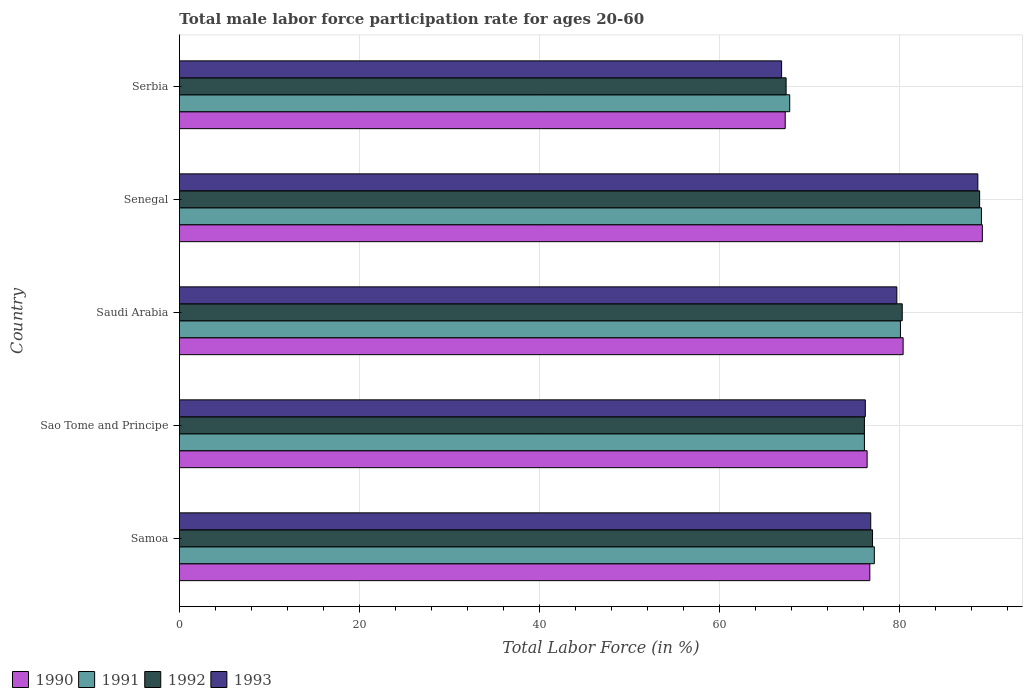How many groups of bars are there?
Your answer should be very brief. 5. Are the number of bars on each tick of the Y-axis equal?
Offer a very short reply. Yes. What is the label of the 4th group of bars from the top?
Provide a succinct answer. Sao Tome and Principe. What is the male labor force participation rate in 1991 in Samoa?
Keep it short and to the point. 77.2. Across all countries, what is the maximum male labor force participation rate in 1992?
Provide a succinct answer. 88.9. Across all countries, what is the minimum male labor force participation rate in 1990?
Give a very brief answer. 67.3. In which country was the male labor force participation rate in 1991 maximum?
Make the answer very short. Senegal. In which country was the male labor force participation rate in 1990 minimum?
Your answer should be compact. Serbia. What is the total male labor force participation rate in 1992 in the graph?
Give a very brief answer. 389.7. What is the average male labor force participation rate in 1993 per country?
Your response must be concise. 77.66. What is the difference between the male labor force participation rate in 1991 and male labor force participation rate in 1990 in Saudi Arabia?
Your response must be concise. -0.3. What is the ratio of the male labor force participation rate in 1993 in Sao Tome and Principe to that in Saudi Arabia?
Offer a very short reply. 0.96. Is the male labor force participation rate in 1993 in Samoa less than that in Senegal?
Your response must be concise. Yes. What is the difference between the highest and the second highest male labor force participation rate in 1993?
Make the answer very short. 9. What is the difference between the highest and the lowest male labor force participation rate in 1992?
Keep it short and to the point. 21.5. Is the sum of the male labor force participation rate in 1991 in Samoa and Senegal greater than the maximum male labor force participation rate in 1992 across all countries?
Offer a terse response. Yes. Is it the case that in every country, the sum of the male labor force participation rate in 1990 and male labor force participation rate in 1992 is greater than the sum of male labor force participation rate in 1991 and male labor force participation rate in 1993?
Provide a short and direct response. No. What does the 1st bar from the bottom in Senegal represents?
Your answer should be compact. 1990. How many bars are there?
Provide a short and direct response. 20. Are all the bars in the graph horizontal?
Provide a short and direct response. Yes. Are the values on the major ticks of X-axis written in scientific E-notation?
Make the answer very short. No. Does the graph contain grids?
Your answer should be compact. Yes. How many legend labels are there?
Offer a terse response. 4. How are the legend labels stacked?
Your response must be concise. Horizontal. What is the title of the graph?
Give a very brief answer. Total male labor force participation rate for ages 20-60. What is the label or title of the Y-axis?
Offer a very short reply. Country. What is the Total Labor Force (in %) of 1990 in Samoa?
Your answer should be very brief. 76.7. What is the Total Labor Force (in %) of 1991 in Samoa?
Provide a short and direct response. 77.2. What is the Total Labor Force (in %) of 1992 in Samoa?
Make the answer very short. 77. What is the Total Labor Force (in %) of 1993 in Samoa?
Make the answer very short. 76.8. What is the Total Labor Force (in %) of 1990 in Sao Tome and Principe?
Make the answer very short. 76.4. What is the Total Labor Force (in %) of 1991 in Sao Tome and Principe?
Give a very brief answer. 76.1. What is the Total Labor Force (in %) of 1992 in Sao Tome and Principe?
Your answer should be very brief. 76.1. What is the Total Labor Force (in %) of 1993 in Sao Tome and Principe?
Provide a succinct answer. 76.2. What is the Total Labor Force (in %) in 1990 in Saudi Arabia?
Offer a terse response. 80.4. What is the Total Labor Force (in %) in 1991 in Saudi Arabia?
Your response must be concise. 80.1. What is the Total Labor Force (in %) in 1992 in Saudi Arabia?
Offer a very short reply. 80.3. What is the Total Labor Force (in %) in 1993 in Saudi Arabia?
Offer a very short reply. 79.7. What is the Total Labor Force (in %) in 1990 in Senegal?
Offer a terse response. 89.2. What is the Total Labor Force (in %) of 1991 in Senegal?
Offer a terse response. 89.1. What is the Total Labor Force (in %) in 1992 in Senegal?
Give a very brief answer. 88.9. What is the Total Labor Force (in %) of 1993 in Senegal?
Make the answer very short. 88.7. What is the Total Labor Force (in %) of 1990 in Serbia?
Your response must be concise. 67.3. What is the Total Labor Force (in %) in 1991 in Serbia?
Provide a succinct answer. 67.8. What is the Total Labor Force (in %) in 1992 in Serbia?
Provide a succinct answer. 67.4. What is the Total Labor Force (in %) in 1993 in Serbia?
Offer a very short reply. 66.9. Across all countries, what is the maximum Total Labor Force (in %) in 1990?
Offer a very short reply. 89.2. Across all countries, what is the maximum Total Labor Force (in %) of 1991?
Give a very brief answer. 89.1. Across all countries, what is the maximum Total Labor Force (in %) in 1992?
Keep it short and to the point. 88.9. Across all countries, what is the maximum Total Labor Force (in %) of 1993?
Offer a terse response. 88.7. Across all countries, what is the minimum Total Labor Force (in %) in 1990?
Provide a succinct answer. 67.3. Across all countries, what is the minimum Total Labor Force (in %) in 1991?
Keep it short and to the point. 67.8. Across all countries, what is the minimum Total Labor Force (in %) in 1992?
Give a very brief answer. 67.4. Across all countries, what is the minimum Total Labor Force (in %) of 1993?
Your answer should be very brief. 66.9. What is the total Total Labor Force (in %) of 1990 in the graph?
Keep it short and to the point. 390. What is the total Total Labor Force (in %) of 1991 in the graph?
Your answer should be very brief. 390.3. What is the total Total Labor Force (in %) of 1992 in the graph?
Give a very brief answer. 389.7. What is the total Total Labor Force (in %) in 1993 in the graph?
Offer a terse response. 388.3. What is the difference between the Total Labor Force (in %) of 1991 in Samoa and that in Sao Tome and Principe?
Give a very brief answer. 1.1. What is the difference between the Total Labor Force (in %) of 1992 in Samoa and that in Senegal?
Provide a short and direct response. -11.9. What is the difference between the Total Labor Force (in %) in 1991 in Samoa and that in Serbia?
Provide a short and direct response. 9.4. What is the difference between the Total Labor Force (in %) in 1992 in Samoa and that in Serbia?
Keep it short and to the point. 9.6. What is the difference between the Total Labor Force (in %) in 1993 in Samoa and that in Serbia?
Make the answer very short. 9.9. What is the difference between the Total Labor Force (in %) in 1991 in Sao Tome and Principe and that in Saudi Arabia?
Ensure brevity in your answer.  -4. What is the difference between the Total Labor Force (in %) in 1992 in Sao Tome and Principe and that in Saudi Arabia?
Provide a succinct answer. -4.2. What is the difference between the Total Labor Force (in %) of 1990 in Sao Tome and Principe and that in Senegal?
Ensure brevity in your answer.  -12.8. What is the difference between the Total Labor Force (in %) in 1993 in Sao Tome and Principe and that in Senegal?
Ensure brevity in your answer.  -12.5. What is the difference between the Total Labor Force (in %) of 1992 in Sao Tome and Principe and that in Serbia?
Make the answer very short. 8.7. What is the difference between the Total Labor Force (in %) of 1991 in Saudi Arabia and that in Senegal?
Make the answer very short. -9. What is the difference between the Total Labor Force (in %) in 1992 in Saudi Arabia and that in Senegal?
Your answer should be very brief. -8.6. What is the difference between the Total Labor Force (in %) of 1993 in Saudi Arabia and that in Senegal?
Your answer should be very brief. -9. What is the difference between the Total Labor Force (in %) of 1992 in Saudi Arabia and that in Serbia?
Provide a succinct answer. 12.9. What is the difference between the Total Labor Force (in %) of 1993 in Saudi Arabia and that in Serbia?
Provide a succinct answer. 12.8. What is the difference between the Total Labor Force (in %) in 1990 in Senegal and that in Serbia?
Ensure brevity in your answer.  21.9. What is the difference between the Total Labor Force (in %) of 1991 in Senegal and that in Serbia?
Your answer should be compact. 21.3. What is the difference between the Total Labor Force (in %) of 1992 in Senegal and that in Serbia?
Offer a terse response. 21.5. What is the difference between the Total Labor Force (in %) of 1993 in Senegal and that in Serbia?
Make the answer very short. 21.8. What is the difference between the Total Labor Force (in %) in 1991 in Samoa and the Total Labor Force (in %) in 1992 in Sao Tome and Principe?
Keep it short and to the point. 1.1. What is the difference between the Total Labor Force (in %) of 1992 in Samoa and the Total Labor Force (in %) of 1993 in Sao Tome and Principe?
Your answer should be very brief. 0.8. What is the difference between the Total Labor Force (in %) in 1990 in Samoa and the Total Labor Force (in %) in 1991 in Senegal?
Give a very brief answer. -12.4. What is the difference between the Total Labor Force (in %) of 1990 in Samoa and the Total Labor Force (in %) of 1992 in Senegal?
Keep it short and to the point. -12.2. What is the difference between the Total Labor Force (in %) in 1990 in Samoa and the Total Labor Force (in %) in 1993 in Senegal?
Ensure brevity in your answer.  -12. What is the difference between the Total Labor Force (in %) of 1991 in Samoa and the Total Labor Force (in %) of 1992 in Senegal?
Your response must be concise. -11.7. What is the difference between the Total Labor Force (in %) in 1990 in Samoa and the Total Labor Force (in %) in 1992 in Serbia?
Ensure brevity in your answer.  9.3. What is the difference between the Total Labor Force (in %) in 1990 in Samoa and the Total Labor Force (in %) in 1993 in Serbia?
Give a very brief answer. 9.8. What is the difference between the Total Labor Force (in %) in 1991 in Samoa and the Total Labor Force (in %) in 1993 in Serbia?
Provide a short and direct response. 10.3. What is the difference between the Total Labor Force (in %) of 1992 in Samoa and the Total Labor Force (in %) of 1993 in Serbia?
Offer a terse response. 10.1. What is the difference between the Total Labor Force (in %) in 1990 in Sao Tome and Principe and the Total Labor Force (in %) in 1992 in Saudi Arabia?
Your answer should be compact. -3.9. What is the difference between the Total Labor Force (in %) of 1990 in Sao Tome and Principe and the Total Labor Force (in %) of 1993 in Saudi Arabia?
Your response must be concise. -3.3. What is the difference between the Total Labor Force (in %) in 1992 in Sao Tome and Principe and the Total Labor Force (in %) in 1993 in Saudi Arabia?
Your answer should be compact. -3.6. What is the difference between the Total Labor Force (in %) of 1990 in Sao Tome and Principe and the Total Labor Force (in %) of 1991 in Senegal?
Your answer should be very brief. -12.7. What is the difference between the Total Labor Force (in %) of 1990 in Sao Tome and Principe and the Total Labor Force (in %) of 1992 in Senegal?
Give a very brief answer. -12.5. What is the difference between the Total Labor Force (in %) in 1991 in Sao Tome and Principe and the Total Labor Force (in %) in 1992 in Senegal?
Keep it short and to the point. -12.8. What is the difference between the Total Labor Force (in %) of 1992 in Sao Tome and Principe and the Total Labor Force (in %) of 1993 in Senegal?
Provide a short and direct response. -12.6. What is the difference between the Total Labor Force (in %) in 1990 in Sao Tome and Principe and the Total Labor Force (in %) in 1991 in Serbia?
Provide a succinct answer. 8.6. What is the difference between the Total Labor Force (in %) in 1990 in Sao Tome and Principe and the Total Labor Force (in %) in 1992 in Serbia?
Provide a succinct answer. 9. What is the difference between the Total Labor Force (in %) in 1990 in Saudi Arabia and the Total Labor Force (in %) in 1991 in Senegal?
Your answer should be very brief. -8.7. What is the difference between the Total Labor Force (in %) of 1990 in Saudi Arabia and the Total Labor Force (in %) of 1992 in Senegal?
Give a very brief answer. -8.5. What is the difference between the Total Labor Force (in %) in 1991 in Saudi Arabia and the Total Labor Force (in %) in 1992 in Senegal?
Provide a succinct answer. -8.8. What is the difference between the Total Labor Force (in %) in 1991 in Saudi Arabia and the Total Labor Force (in %) in 1993 in Senegal?
Offer a very short reply. -8.6. What is the difference between the Total Labor Force (in %) in 1990 in Saudi Arabia and the Total Labor Force (in %) in 1991 in Serbia?
Give a very brief answer. 12.6. What is the difference between the Total Labor Force (in %) in 1990 in Saudi Arabia and the Total Labor Force (in %) in 1992 in Serbia?
Make the answer very short. 13. What is the difference between the Total Labor Force (in %) of 1990 in Senegal and the Total Labor Force (in %) of 1991 in Serbia?
Offer a very short reply. 21.4. What is the difference between the Total Labor Force (in %) of 1990 in Senegal and the Total Labor Force (in %) of 1992 in Serbia?
Offer a very short reply. 21.8. What is the difference between the Total Labor Force (in %) in 1990 in Senegal and the Total Labor Force (in %) in 1993 in Serbia?
Offer a terse response. 22.3. What is the difference between the Total Labor Force (in %) of 1991 in Senegal and the Total Labor Force (in %) of 1992 in Serbia?
Your response must be concise. 21.7. What is the difference between the Total Labor Force (in %) in 1992 in Senegal and the Total Labor Force (in %) in 1993 in Serbia?
Ensure brevity in your answer.  22. What is the average Total Labor Force (in %) in 1991 per country?
Your answer should be compact. 78.06. What is the average Total Labor Force (in %) in 1992 per country?
Ensure brevity in your answer.  77.94. What is the average Total Labor Force (in %) of 1993 per country?
Your answer should be compact. 77.66. What is the difference between the Total Labor Force (in %) of 1991 and Total Labor Force (in %) of 1992 in Samoa?
Make the answer very short. 0.2. What is the difference between the Total Labor Force (in %) in 1991 and Total Labor Force (in %) in 1993 in Samoa?
Keep it short and to the point. 0.4. What is the difference between the Total Labor Force (in %) of 1990 and Total Labor Force (in %) of 1991 in Sao Tome and Principe?
Provide a succinct answer. 0.3. What is the difference between the Total Labor Force (in %) in 1990 and Total Labor Force (in %) in 1993 in Sao Tome and Principe?
Your response must be concise. 0.2. What is the difference between the Total Labor Force (in %) of 1991 and Total Labor Force (in %) of 1992 in Sao Tome and Principe?
Make the answer very short. 0. What is the difference between the Total Labor Force (in %) of 1990 and Total Labor Force (in %) of 1992 in Saudi Arabia?
Ensure brevity in your answer.  0.1. What is the difference between the Total Labor Force (in %) of 1990 and Total Labor Force (in %) of 1993 in Saudi Arabia?
Give a very brief answer. 0.7. What is the difference between the Total Labor Force (in %) in 1991 and Total Labor Force (in %) in 1992 in Saudi Arabia?
Provide a succinct answer. -0.2. What is the difference between the Total Labor Force (in %) in 1992 and Total Labor Force (in %) in 1993 in Saudi Arabia?
Provide a succinct answer. 0.6. What is the difference between the Total Labor Force (in %) in 1990 and Total Labor Force (in %) in 1992 in Senegal?
Provide a succinct answer. 0.3. What is the difference between the Total Labor Force (in %) of 1992 and Total Labor Force (in %) of 1993 in Senegal?
Your response must be concise. 0.2. What is the difference between the Total Labor Force (in %) in 1990 and Total Labor Force (in %) in 1991 in Serbia?
Ensure brevity in your answer.  -0.5. What is the difference between the Total Labor Force (in %) of 1992 and Total Labor Force (in %) of 1993 in Serbia?
Provide a short and direct response. 0.5. What is the ratio of the Total Labor Force (in %) of 1991 in Samoa to that in Sao Tome and Principe?
Your response must be concise. 1.01. What is the ratio of the Total Labor Force (in %) in 1992 in Samoa to that in Sao Tome and Principe?
Make the answer very short. 1.01. What is the ratio of the Total Labor Force (in %) in 1993 in Samoa to that in Sao Tome and Principe?
Make the answer very short. 1.01. What is the ratio of the Total Labor Force (in %) of 1990 in Samoa to that in Saudi Arabia?
Offer a terse response. 0.95. What is the ratio of the Total Labor Force (in %) in 1991 in Samoa to that in Saudi Arabia?
Keep it short and to the point. 0.96. What is the ratio of the Total Labor Force (in %) in 1992 in Samoa to that in Saudi Arabia?
Provide a short and direct response. 0.96. What is the ratio of the Total Labor Force (in %) in 1993 in Samoa to that in Saudi Arabia?
Your response must be concise. 0.96. What is the ratio of the Total Labor Force (in %) of 1990 in Samoa to that in Senegal?
Ensure brevity in your answer.  0.86. What is the ratio of the Total Labor Force (in %) of 1991 in Samoa to that in Senegal?
Ensure brevity in your answer.  0.87. What is the ratio of the Total Labor Force (in %) in 1992 in Samoa to that in Senegal?
Offer a terse response. 0.87. What is the ratio of the Total Labor Force (in %) in 1993 in Samoa to that in Senegal?
Provide a short and direct response. 0.87. What is the ratio of the Total Labor Force (in %) in 1990 in Samoa to that in Serbia?
Offer a terse response. 1.14. What is the ratio of the Total Labor Force (in %) in 1991 in Samoa to that in Serbia?
Ensure brevity in your answer.  1.14. What is the ratio of the Total Labor Force (in %) of 1992 in Samoa to that in Serbia?
Provide a short and direct response. 1.14. What is the ratio of the Total Labor Force (in %) of 1993 in Samoa to that in Serbia?
Provide a succinct answer. 1.15. What is the ratio of the Total Labor Force (in %) of 1990 in Sao Tome and Principe to that in Saudi Arabia?
Ensure brevity in your answer.  0.95. What is the ratio of the Total Labor Force (in %) of 1991 in Sao Tome and Principe to that in Saudi Arabia?
Your answer should be compact. 0.95. What is the ratio of the Total Labor Force (in %) of 1992 in Sao Tome and Principe to that in Saudi Arabia?
Offer a very short reply. 0.95. What is the ratio of the Total Labor Force (in %) of 1993 in Sao Tome and Principe to that in Saudi Arabia?
Your answer should be very brief. 0.96. What is the ratio of the Total Labor Force (in %) of 1990 in Sao Tome and Principe to that in Senegal?
Offer a terse response. 0.86. What is the ratio of the Total Labor Force (in %) of 1991 in Sao Tome and Principe to that in Senegal?
Your answer should be compact. 0.85. What is the ratio of the Total Labor Force (in %) of 1992 in Sao Tome and Principe to that in Senegal?
Keep it short and to the point. 0.86. What is the ratio of the Total Labor Force (in %) in 1993 in Sao Tome and Principe to that in Senegal?
Offer a terse response. 0.86. What is the ratio of the Total Labor Force (in %) in 1990 in Sao Tome and Principe to that in Serbia?
Your answer should be very brief. 1.14. What is the ratio of the Total Labor Force (in %) of 1991 in Sao Tome and Principe to that in Serbia?
Provide a succinct answer. 1.12. What is the ratio of the Total Labor Force (in %) of 1992 in Sao Tome and Principe to that in Serbia?
Provide a succinct answer. 1.13. What is the ratio of the Total Labor Force (in %) in 1993 in Sao Tome and Principe to that in Serbia?
Ensure brevity in your answer.  1.14. What is the ratio of the Total Labor Force (in %) in 1990 in Saudi Arabia to that in Senegal?
Ensure brevity in your answer.  0.9. What is the ratio of the Total Labor Force (in %) of 1991 in Saudi Arabia to that in Senegal?
Your answer should be compact. 0.9. What is the ratio of the Total Labor Force (in %) in 1992 in Saudi Arabia to that in Senegal?
Offer a very short reply. 0.9. What is the ratio of the Total Labor Force (in %) in 1993 in Saudi Arabia to that in Senegal?
Your response must be concise. 0.9. What is the ratio of the Total Labor Force (in %) of 1990 in Saudi Arabia to that in Serbia?
Offer a very short reply. 1.19. What is the ratio of the Total Labor Force (in %) in 1991 in Saudi Arabia to that in Serbia?
Your response must be concise. 1.18. What is the ratio of the Total Labor Force (in %) of 1992 in Saudi Arabia to that in Serbia?
Provide a short and direct response. 1.19. What is the ratio of the Total Labor Force (in %) of 1993 in Saudi Arabia to that in Serbia?
Offer a very short reply. 1.19. What is the ratio of the Total Labor Force (in %) in 1990 in Senegal to that in Serbia?
Offer a terse response. 1.33. What is the ratio of the Total Labor Force (in %) in 1991 in Senegal to that in Serbia?
Keep it short and to the point. 1.31. What is the ratio of the Total Labor Force (in %) of 1992 in Senegal to that in Serbia?
Your response must be concise. 1.32. What is the ratio of the Total Labor Force (in %) in 1993 in Senegal to that in Serbia?
Your answer should be compact. 1.33. What is the difference between the highest and the second highest Total Labor Force (in %) in 1990?
Give a very brief answer. 8.8. What is the difference between the highest and the second highest Total Labor Force (in %) in 1991?
Your answer should be compact. 9. What is the difference between the highest and the second highest Total Labor Force (in %) in 1992?
Your response must be concise. 8.6. What is the difference between the highest and the second highest Total Labor Force (in %) of 1993?
Your answer should be very brief. 9. What is the difference between the highest and the lowest Total Labor Force (in %) in 1990?
Your response must be concise. 21.9. What is the difference between the highest and the lowest Total Labor Force (in %) of 1991?
Provide a short and direct response. 21.3. What is the difference between the highest and the lowest Total Labor Force (in %) in 1992?
Ensure brevity in your answer.  21.5. What is the difference between the highest and the lowest Total Labor Force (in %) of 1993?
Offer a terse response. 21.8. 